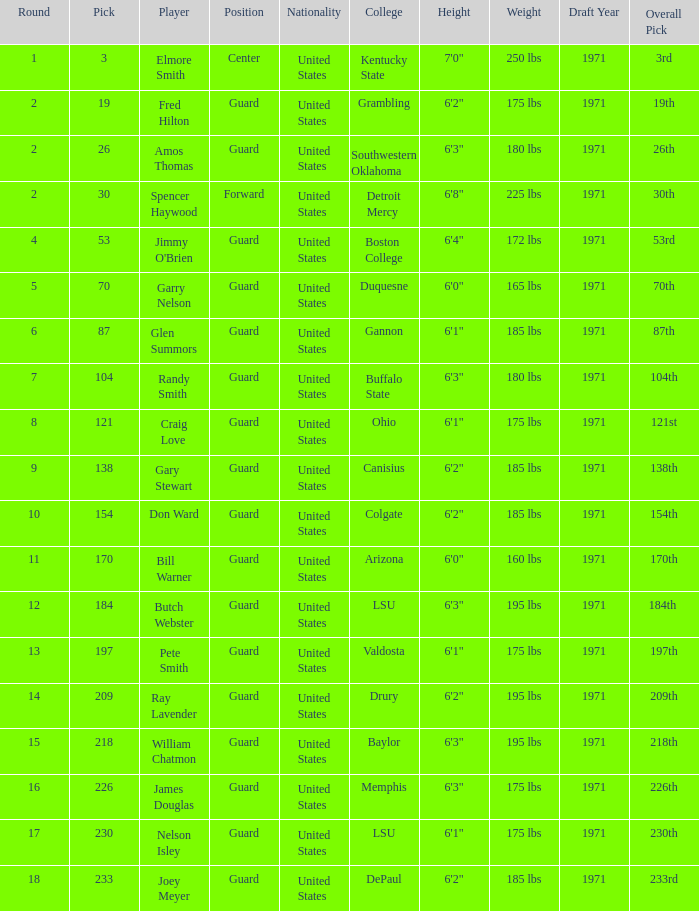WHAT IS THE TOTAL PICK FOR BOSTON COLLEGE? 1.0. 